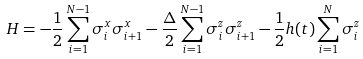Convert formula to latex. <formula><loc_0><loc_0><loc_500><loc_500>H = - \frac { 1 } { 2 } \sum _ { i = 1 } ^ { N - 1 } \sigma ^ { x } _ { i } \sigma ^ { x } _ { i + 1 } - \frac { \Delta } { 2 } \sum _ { i = 1 } ^ { N - 1 } \sigma ^ { z } _ { i } \sigma ^ { z } _ { i + 1 } - \frac { 1 } { 2 } h ( t ) \sum _ { i = 1 } ^ { N } \sigma ^ { z } _ { i }</formula> 